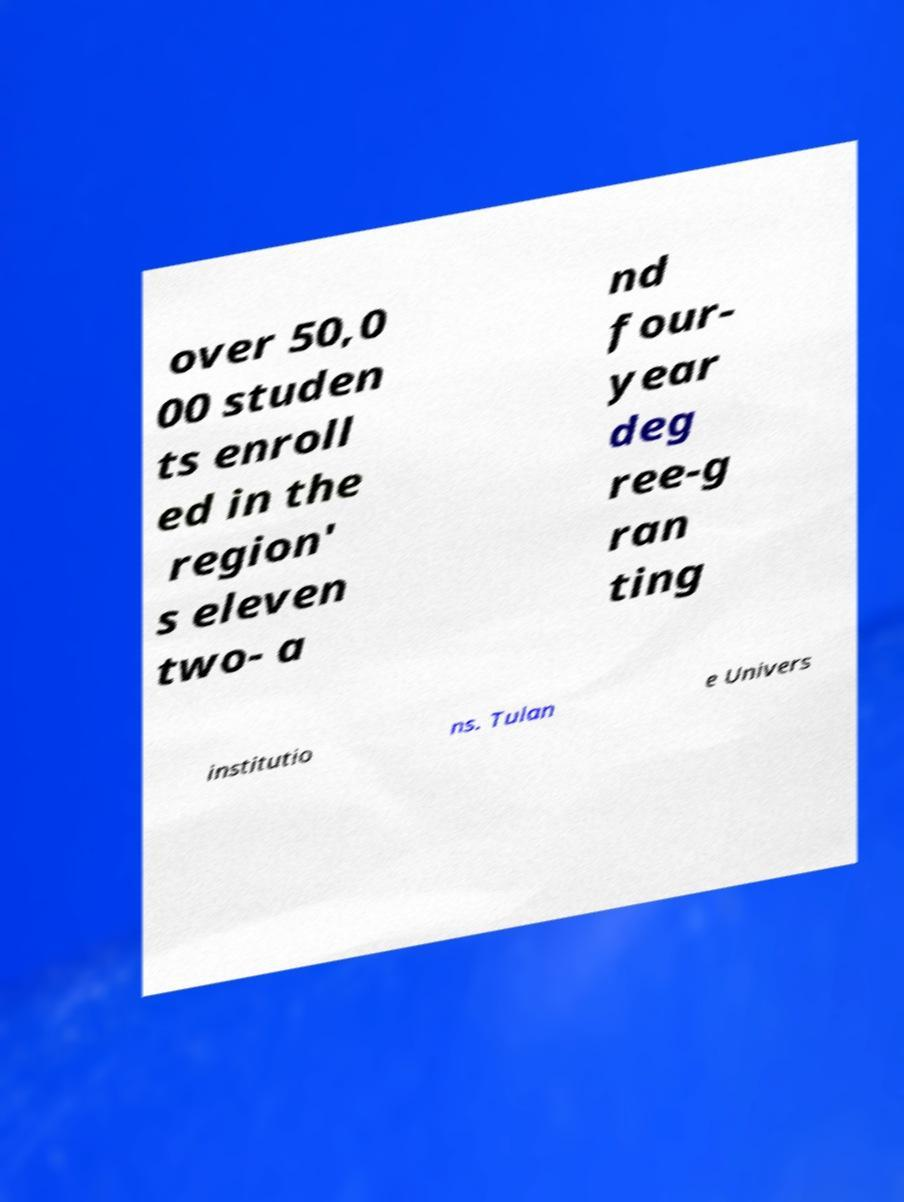Can you accurately transcribe the text from the provided image for me? over 50,0 00 studen ts enroll ed in the region' s eleven two- a nd four- year deg ree-g ran ting institutio ns. Tulan e Univers 